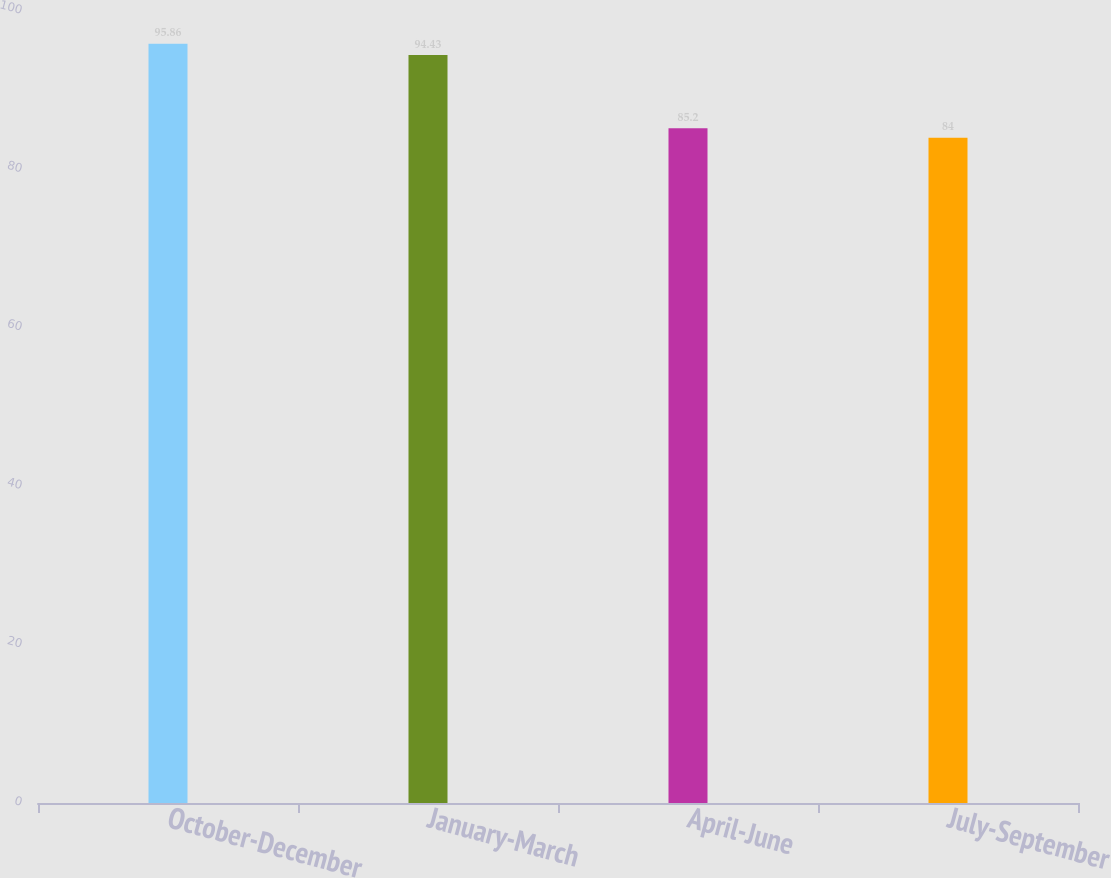Convert chart. <chart><loc_0><loc_0><loc_500><loc_500><bar_chart><fcel>October-December<fcel>January-March<fcel>April-June<fcel>July-September<nl><fcel>95.86<fcel>94.43<fcel>85.2<fcel>84<nl></chart> 